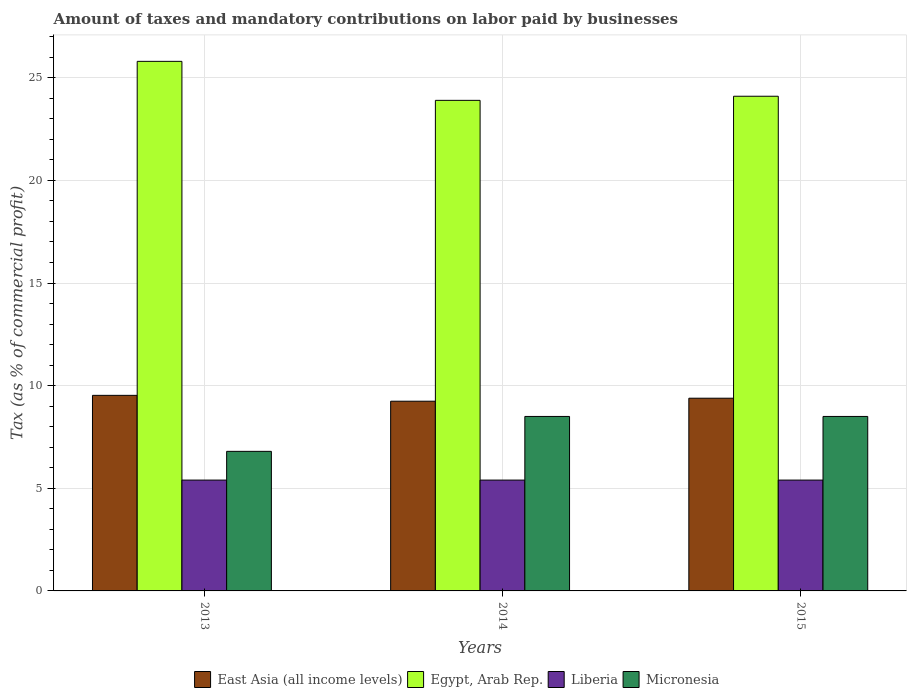How many different coloured bars are there?
Offer a terse response. 4. How many groups of bars are there?
Offer a very short reply. 3. Are the number of bars per tick equal to the number of legend labels?
Make the answer very short. Yes. Are the number of bars on each tick of the X-axis equal?
Give a very brief answer. Yes. How many bars are there on the 2nd tick from the right?
Keep it short and to the point. 4. What is the label of the 2nd group of bars from the left?
Offer a very short reply. 2014. Across all years, what is the maximum percentage of taxes paid by businesses in East Asia (all income levels)?
Make the answer very short. 9.53. Across all years, what is the minimum percentage of taxes paid by businesses in Egypt, Arab Rep.?
Your answer should be compact. 23.9. In which year was the percentage of taxes paid by businesses in Liberia maximum?
Offer a terse response. 2013. In which year was the percentage of taxes paid by businesses in East Asia (all income levels) minimum?
Give a very brief answer. 2014. What is the total percentage of taxes paid by businesses in Egypt, Arab Rep. in the graph?
Offer a terse response. 73.8. What is the difference between the percentage of taxes paid by businesses in Liberia in 2013 and that in 2014?
Provide a succinct answer. 0. What is the difference between the percentage of taxes paid by businesses in East Asia (all income levels) in 2015 and the percentage of taxes paid by businesses in Egypt, Arab Rep. in 2014?
Offer a terse response. -14.51. What is the average percentage of taxes paid by businesses in Egypt, Arab Rep. per year?
Your answer should be very brief. 24.6. In the year 2013, what is the difference between the percentage of taxes paid by businesses in East Asia (all income levels) and percentage of taxes paid by businesses in Egypt, Arab Rep.?
Your response must be concise. -16.27. What is the ratio of the percentage of taxes paid by businesses in East Asia (all income levels) in 2013 to that in 2015?
Your answer should be very brief. 1.01. Is the percentage of taxes paid by businesses in Egypt, Arab Rep. in 2013 less than that in 2015?
Your answer should be very brief. No. What is the difference between the highest and the lowest percentage of taxes paid by businesses in Egypt, Arab Rep.?
Make the answer very short. 1.9. Is the sum of the percentage of taxes paid by businesses in Liberia in 2014 and 2015 greater than the maximum percentage of taxes paid by businesses in East Asia (all income levels) across all years?
Provide a short and direct response. Yes. What does the 1st bar from the left in 2014 represents?
Give a very brief answer. East Asia (all income levels). What does the 2nd bar from the right in 2013 represents?
Provide a succinct answer. Liberia. Is it the case that in every year, the sum of the percentage of taxes paid by businesses in Micronesia and percentage of taxes paid by businesses in Egypt, Arab Rep. is greater than the percentage of taxes paid by businesses in East Asia (all income levels)?
Ensure brevity in your answer.  Yes. How many bars are there?
Provide a succinct answer. 12. Are all the bars in the graph horizontal?
Offer a terse response. No. How many years are there in the graph?
Make the answer very short. 3. Are the values on the major ticks of Y-axis written in scientific E-notation?
Your answer should be compact. No. What is the title of the graph?
Your response must be concise. Amount of taxes and mandatory contributions on labor paid by businesses. Does "Lebanon" appear as one of the legend labels in the graph?
Your answer should be very brief. No. What is the label or title of the Y-axis?
Ensure brevity in your answer.  Tax (as % of commercial profit). What is the Tax (as % of commercial profit) of East Asia (all income levels) in 2013?
Offer a terse response. 9.53. What is the Tax (as % of commercial profit) in Egypt, Arab Rep. in 2013?
Your answer should be compact. 25.8. What is the Tax (as % of commercial profit) in East Asia (all income levels) in 2014?
Give a very brief answer. 9.24. What is the Tax (as % of commercial profit) of Egypt, Arab Rep. in 2014?
Give a very brief answer. 23.9. What is the Tax (as % of commercial profit) in Liberia in 2014?
Offer a very short reply. 5.4. What is the Tax (as % of commercial profit) in East Asia (all income levels) in 2015?
Ensure brevity in your answer.  9.39. What is the Tax (as % of commercial profit) in Egypt, Arab Rep. in 2015?
Provide a succinct answer. 24.1. What is the Tax (as % of commercial profit) in Micronesia in 2015?
Provide a short and direct response. 8.5. Across all years, what is the maximum Tax (as % of commercial profit) of East Asia (all income levels)?
Offer a very short reply. 9.53. Across all years, what is the maximum Tax (as % of commercial profit) of Egypt, Arab Rep.?
Offer a very short reply. 25.8. Across all years, what is the maximum Tax (as % of commercial profit) of Micronesia?
Offer a very short reply. 8.5. Across all years, what is the minimum Tax (as % of commercial profit) in East Asia (all income levels)?
Offer a very short reply. 9.24. Across all years, what is the minimum Tax (as % of commercial profit) in Egypt, Arab Rep.?
Ensure brevity in your answer.  23.9. Across all years, what is the minimum Tax (as % of commercial profit) of Liberia?
Make the answer very short. 5.4. What is the total Tax (as % of commercial profit) in East Asia (all income levels) in the graph?
Provide a short and direct response. 28.16. What is the total Tax (as % of commercial profit) of Egypt, Arab Rep. in the graph?
Offer a terse response. 73.8. What is the total Tax (as % of commercial profit) in Micronesia in the graph?
Your answer should be compact. 23.8. What is the difference between the Tax (as % of commercial profit) of East Asia (all income levels) in 2013 and that in 2014?
Make the answer very short. 0.29. What is the difference between the Tax (as % of commercial profit) of Egypt, Arab Rep. in 2013 and that in 2014?
Ensure brevity in your answer.  1.9. What is the difference between the Tax (as % of commercial profit) of Liberia in 2013 and that in 2014?
Give a very brief answer. 0. What is the difference between the Tax (as % of commercial profit) of Micronesia in 2013 and that in 2014?
Your response must be concise. -1.7. What is the difference between the Tax (as % of commercial profit) of East Asia (all income levels) in 2013 and that in 2015?
Ensure brevity in your answer.  0.14. What is the difference between the Tax (as % of commercial profit) of East Asia (all income levels) in 2014 and that in 2015?
Your response must be concise. -0.15. What is the difference between the Tax (as % of commercial profit) in Egypt, Arab Rep. in 2014 and that in 2015?
Provide a succinct answer. -0.2. What is the difference between the Tax (as % of commercial profit) of Liberia in 2014 and that in 2015?
Make the answer very short. 0. What is the difference between the Tax (as % of commercial profit) of Micronesia in 2014 and that in 2015?
Give a very brief answer. 0. What is the difference between the Tax (as % of commercial profit) of East Asia (all income levels) in 2013 and the Tax (as % of commercial profit) of Egypt, Arab Rep. in 2014?
Give a very brief answer. -14.37. What is the difference between the Tax (as % of commercial profit) in East Asia (all income levels) in 2013 and the Tax (as % of commercial profit) in Liberia in 2014?
Offer a very short reply. 4.13. What is the difference between the Tax (as % of commercial profit) in East Asia (all income levels) in 2013 and the Tax (as % of commercial profit) in Micronesia in 2014?
Your answer should be compact. 1.03. What is the difference between the Tax (as % of commercial profit) in Egypt, Arab Rep. in 2013 and the Tax (as % of commercial profit) in Liberia in 2014?
Provide a succinct answer. 20.4. What is the difference between the Tax (as % of commercial profit) in Liberia in 2013 and the Tax (as % of commercial profit) in Micronesia in 2014?
Offer a terse response. -3.1. What is the difference between the Tax (as % of commercial profit) of East Asia (all income levels) in 2013 and the Tax (as % of commercial profit) of Egypt, Arab Rep. in 2015?
Make the answer very short. -14.57. What is the difference between the Tax (as % of commercial profit) of East Asia (all income levels) in 2013 and the Tax (as % of commercial profit) of Liberia in 2015?
Provide a short and direct response. 4.13. What is the difference between the Tax (as % of commercial profit) of East Asia (all income levels) in 2013 and the Tax (as % of commercial profit) of Micronesia in 2015?
Offer a very short reply. 1.03. What is the difference between the Tax (as % of commercial profit) in Egypt, Arab Rep. in 2013 and the Tax (as % of commercial profit) in Liberia in 2015?
Ensure brevity in your answer.  20.4. What is the difference between the Tax (as % of commercial profit) in Egypt, Arab Rep. in 2013 and the Tax (as % of commercial profit) in Micronesia in 2015?
Provide a short and direct response. 17.3. What is the difference between the Tax (as % of commercial profit) in East Asia (all income levels) in 2014 and the Tax (as % of commercial profit) in Egypt, Arab Rep. in 2015?
Your response must be concise. -14.86. What is the difference between the Tax (as % of commercial profit) of East Asia (all income levels) in 2014 and the Tax (as % of commercial profit) of Liberia in 2015?
Offer a very short reply. 3.84. What is the difference between the Tax (as % of commercial profit) in East Asia (all income levels) in 2014 and the Tax (as % of commercial profit) in Micronesia in 2015?
Your answer should be compact. 0.74. What is the difference between the Tax (as % of commercial profit) in Egypt, Arab Rep. in 2014 and the Tax (as % of commercial profit) in Micronesia in 2015?
Provide a short and direct response. 15.4. What is the difference between the Tax (as % of commercial profit) in Liberia in 2014 and the Tax (as % of commercial profit) in Micronesia in 2015?
Your answer should be compact. -3.1. What is the average Tax (as % of commercial profit) in East Asia (all income levels) per year?
Make the answer very short. 9.39. What is the average Tax (as % of commercial profit) in Egypt, Arab Rep. per year?
Offer a terse response. 24.6. What is the average Tax (as % of commercial profit) of Micronesia per year?
Ensure brevity in your answer.  7.93. In the year 2013, what is the difference between the Tax (as % of commercial profit) in East Asia (all income levels) and Tax (as % of commercial profit) in Egypt, Arab Rep.?
Provide a succinct answer. -16.27. In the year 2013, what is the difference between the Tax (as % of commercial profit) in East Asia (all income levels) and Tax (as % of commercial profit) in Liberia?
Keep it short and to the point. 4.13. In the year 2013, what is the difference between the Tax (as % of commercial profit) of East Asia (all income levels) and Tax (as % of commercial profit) of Micronesia?
Provide a short and direct response. 2.73. In the year 2013, what is the difference between the Tax (as % of commercial profit) in Egypt, Arab Rep. and Tax (as % of commercial profit) in Liberia?
Offer a very short reply. 20.4. In the year 2013, what is the difference between the Tax (as % of commercial profit) in Egypt, Arab Rep. and Tax (as % of commercial profit) in Micronesia?
Provide a succinct answer. 19. In the year 2014, what is the difference between the Tax (as % of commercial profit) in East Asia (all income levels) and Tax (as % of commercial profit) in Egypt, Arab Rep.?
Give a very brief answer. -14.66. In the year 2014, what is the difference between the Tax (as % of commercial profit) of East Asia (all income levels) and Tax (as % of commercial profit) of Liberia?
Your response must be concise. 3.84. In the year 2014, what is the difference between the Tax (as % of commercial profit) in East Asia (all income levels) and Tax (as % of commercial profit) in Micronesia?
Provide a short and direct response. 0.74. In the year 2014, what is the difference between the Tax (as % of commercial profit) in Egypt, Arab Rep. and Tax (as % of commercial profit) in Liberia?
Provide a succinct answer. 18.5. In the year 2014, what is the difference between the Tax (as % of commercial profit) of Egypt, Arab Rep. and Tax (as % of commercial profit) of Micronesia?
Provide a succinct answer. 15.4. In the year 2015, what is the difference between the Tax (as % of commercial profit) of East Asia (all income levels) and Tax (as % of commercial profit) of Egypt, Arab Rep.?
Give a very brief answer. -14.71. In the year 2015, what is the difference between the Tax (as % of commercial profit) of East Asia (all income levels) and Tax (as % of commercial profit) of Liberia?
Your answer should be compact. 3.99. In the year 2015, what is the difference between the Tax (as % of commercial profit) in East Asia (all income levels) and Tax (as % of commercial profit) in Micronesia?
Provide a short and direct response. 0.89. In the year 2015, what is the difference between the Tax (as % of commercial profit) of Egypt, Arab Rep. and Tax (as % of commercial profit) of Liberia?
Provide a succinct answer. 18.7. In the year 2015, what is the difference between the Tax (as % of commercial profit) in Egypt, Arab Rep. and Tax (as % of commercial profit) in Micronesia?
Make the answer very short. 15.6. What is the ratio of the Tax (as % of commercial profit) of East Asia (all income levels) in 2013 to that in 2014?
Give a very brief answer. 1.03. What is the ratio of the Tax (as % of commercial profit) in Egypt, Arab Rep. in 2013 to that in 2014?
Keep it short and to the point. 1.08. What is the ratio of the Tax (as % of commercial profit) in Micronesia in 2013 to that in 2014?
Offer a terse response. 0.8. What is the ratio of the Tax (as % of commercial profit) of East Asia (all income levels) in 2013 to that in 2015?
Offer a very short reply. 1.01. What is the ratio of the Tax (as % of commercial profit) of Egypt, Arab Rep. in 2013 to that in 2015?
Offer a very short reply. 1.07. What is the ratio of the Tax (as % of commercial profit) of Liberia in 2013 to that in 2015?
Provide a short and direct response. 1. What is the ratio of the Tax (as % of commercial profit) in Micronesia in 2013 to that in 2015?
Offer a terse response. 0.8. What is the ratio of the Tax (as % of commercial profit) in East Asia (all income levels) in 2014 to that in 2015?
Your answer should be very brief. 0.98. What is the ratio of the Tax (as % of commercial profit) of Egypt, Arab Rep. in 2014 to that in 2015?
Ensure brevity in your answer.  0.99. What is the ratio of the Tax (as % of commercial profit) of Liberia in 2014 to that in 2015?
Offer a very short reply. 1. What is the difference between the highest and the second highest Tax (as % of commercial profit) of East Asia (all income levels)?
Your answer should be compact. 0.14. What is the difference between the highest and the lowest Tax (as % of commercial profit) in East Asia (all income levels)?
Give a very brief answer. 0.29. What is the difference between the highest and the lowest Tax (as % of commercial profit) of Egypt, Arab Rep.?
Provide a short and direct response. 1.9. What is the difference between the highest and the lowest Tax (as % of commercial profit) in Liberia?
Give a very brief answer. 0. 